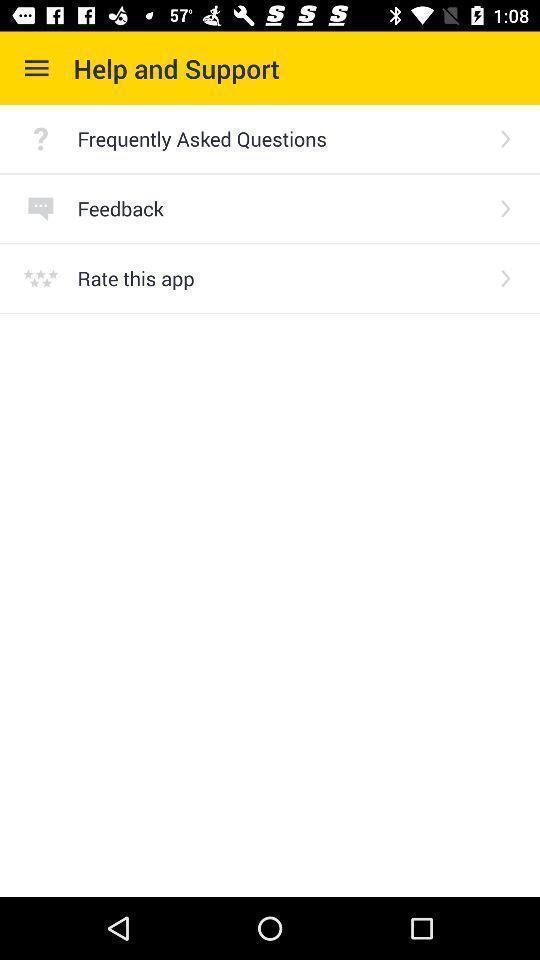Give me a summary of this screen capture. Screen displaying help and support page. 